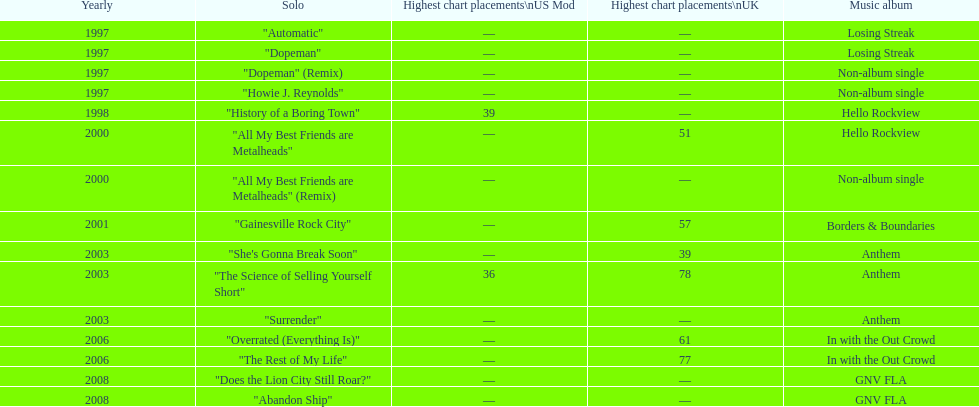What was the first single to earn a chart position? "History of a Boring Town". Help me parse the entirety of this table. {'header': ['Yearly', 'Solo', 'Highest chart placements\\nUS Mod', 'Highest chart placements\\nUK', 'Music album'], 'rows': [['1997', '"Automatic"', '—', '—', 'Losing Streak'], ['1997', '"Dopeman"', '—', '—', 'Losing Streak'], ['1997', '"Dopeman" (Remix)', '—', '—', 'Non-album single'], ['1997', '"Howie J. Reynolds"', '—', '—', 'Non-album single'], ['1998', '"History of a Boring Town"', '39', '—', 'Hello Rockview'], ['2000', '"All My Best Friends are Metalheads"', '—', '51', 'Hello Rockview'], ['2000', '"All My Best Friends are Metalheads" (Remix)', '—', '—', 'Non-album single'], ['2001', '"Gainesville Rock City"', '—', '57', 'Borders & Boundaries'], ['2003', '"She\'s Gonna Break Soon"', '—', '39', 'Anthem'], ['2003', '"The Science of Selling Yourself Short"', '36', '78', 'Anthem'], ['2003', '"Surrender"', '—', '—', 'Anthem'], ['2006', '"Overrated (Everything Is)"', '—', '61', 'In with the Out Crowd'], ['2006', '"The Rest of My Life"', '—', '77', 'In with the Out Crowd'], ['2008', '"Does the Lion City Still Roar?"', '—', '—', 'GNV FLA'], ['2008', '"Abandon Ship"', '—', '—', 'GNV FLA']]} 